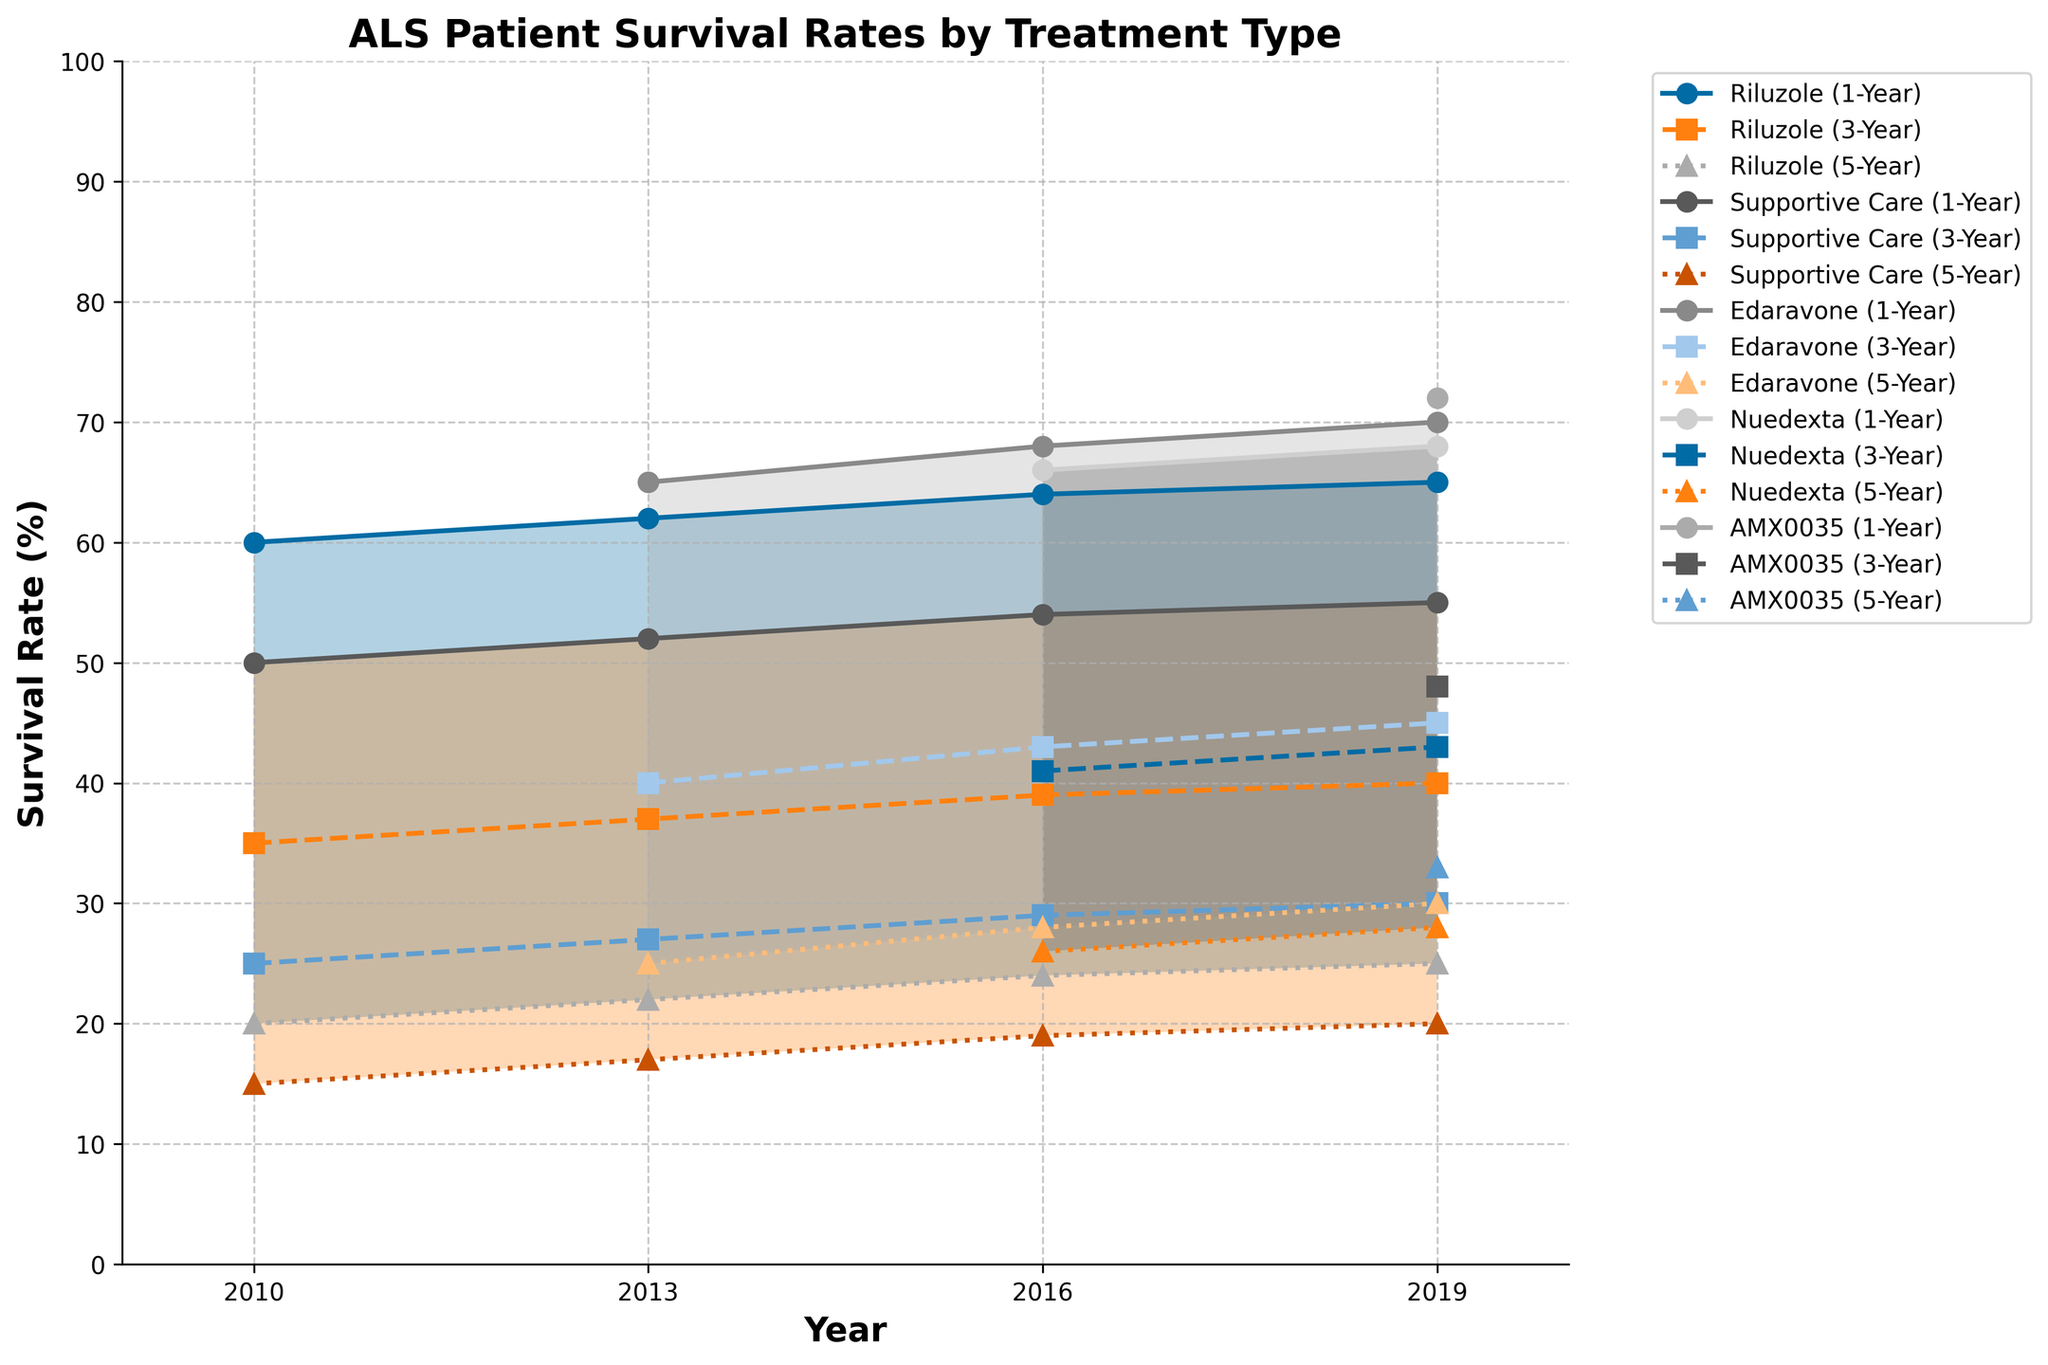What is the title of the figure? The title of the figure is prominently displayed at the top and provides a clear description of what the chart represents.
Answer: ALS Patient Survival Rates by Treatment Type What range does the x-axis cover? The x-axis represents the year and the range can be identified by looking at the extreme ends of the axis labels.
Answer: 2009 to 2020 How does the 1-year survival rate of Riluzole change from 2010 to 2019? Follow the line marked as "Riluzole (1-Year)" from 2010 to 2019 and check the change in values at each year marker.
Answer: Increases from 60% to 65% Which treatment shows the highest 3-year survival rate in 2019? Look at the endpoints marked with "2019" and compare the 3-Year survival rate lines for each treatment.
Answer: AMX0035 What is the difference in the 5-year survival rate between Edaravone and Supportive Care in 2016? Find the points on the graph for Edaravone and Supportive Care in 2016, then subtract the 5-year rate of Supportive Care from that of Edaravone.
Answer: 28 - 19 = 9% Which treatment introduced after 2013 shows a steady increase in survival rates across all three metrics? Identify treatments not present in the 2013 data, then analyze their survival rate trends from their introduction year onwards.
Answer: Nuedexta What was the approximate 1-year survival rate for Supportive Care in each year shown? Locate the lines corresponding to "Supportive Care (1-Year)" and note the rate for each year displayed on the x-axis.
Answer: 2010: 50%, 2013: 52%, 2016: 54%, 2019: 55% How does the 3-year survival rate for AMX0035 compare to Riluzole in 2019? Find the 3-year survival data points for both AMX0035 and Riluzole in 2019 and compare them.
Answer: 48% for AMX0035, 40% for Riluzole What is the overall trend in the 5-year survival rates for patients on Supportive Care from 2010 to 2019? Trace the line labeled "Supportive Care (5-Year)" from 2010 to 2019 to observe the trend.
Answer: It shows a slight increase from 15% to 20% What does the shaded area between survival rates for each treatment represent? The shaded area between the different survival rates provides an indication of the range between 1-year and 5-year survival rates through each year for each treatment type.
Answer: The range of survival rates for 1-year to 5-year 